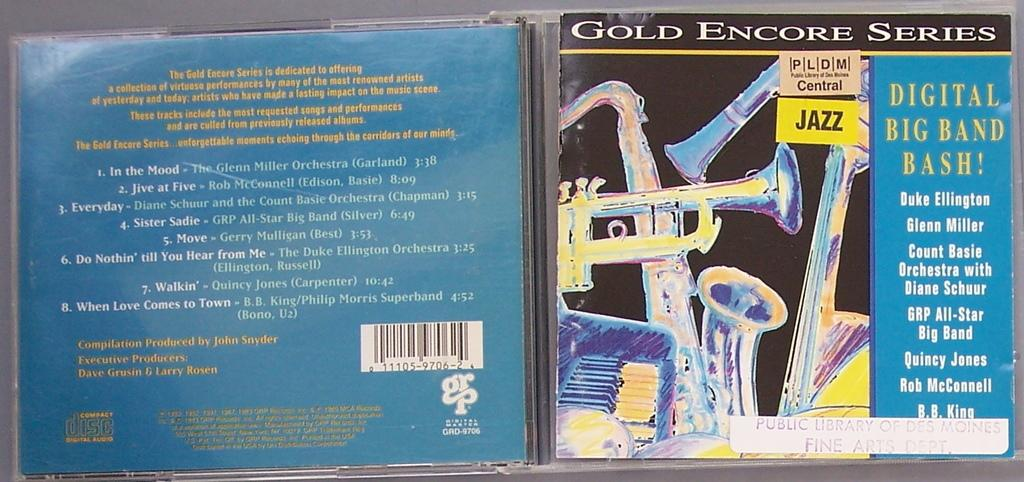<image>
Give a short and clear explanation of the subsequent image. An old Gold encore series blue music CD case 